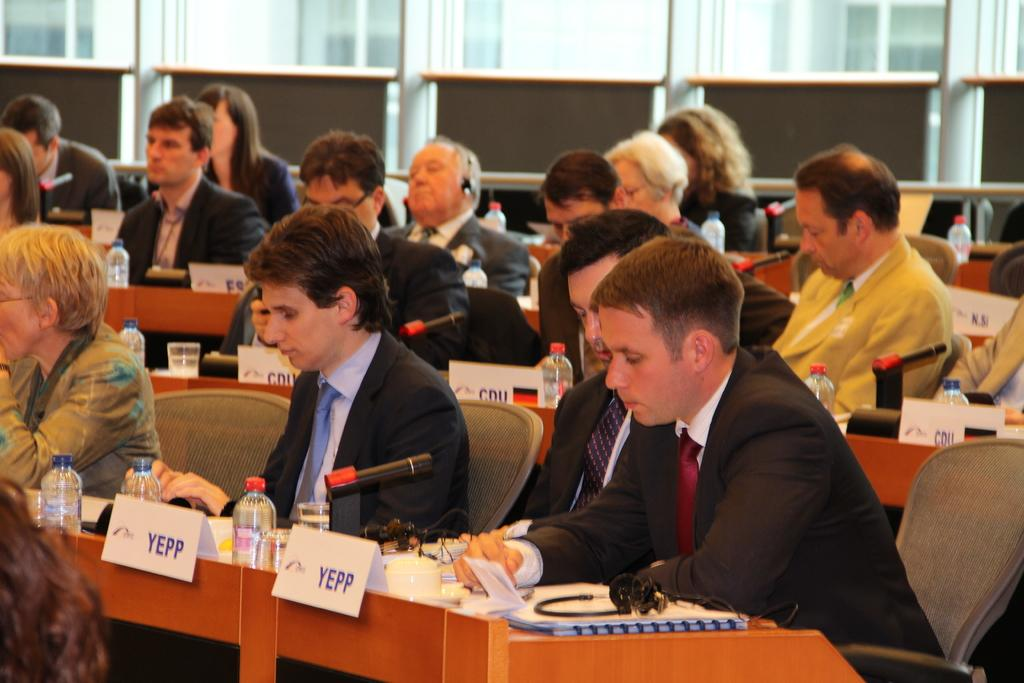What are the people in the image doing? The people in the image are sitting on chairs. What is the main piece of furniture in the image? There is a table in the image. What can be seen on the table? Water bottles are visible in the image. What might be used for amplifying sound in the image? Microphones are present in the image. What type of country can be seen in the image? There is no country visible in the image; it features people sitting on chairs, a table, water bottles, and microphones. Is there a lamp present in the image? There is no lamp visible in the image. 